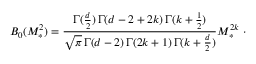Convert formula to latex. <formula><loc_0><loc_0><loc_500><loc_500>B _ { 0 } ( M _ { * } ^ { 2 } ) = \frac { \Gamma ( \frac { d } { 2 } ) \, \Gamma ( d - 2 + 2 k ) \, \Gamma ( k + \frac { 1 } { 2 } ) } { \sqrt { \pi } \, \Gamma ( d - 2 ) \, \Gamma ( 2 k + 1 ) \, \Gamma ( k + \frac { d } { 2 } ) } M _ { \ast } ^ { 2 k } \ \cdot</formula> 